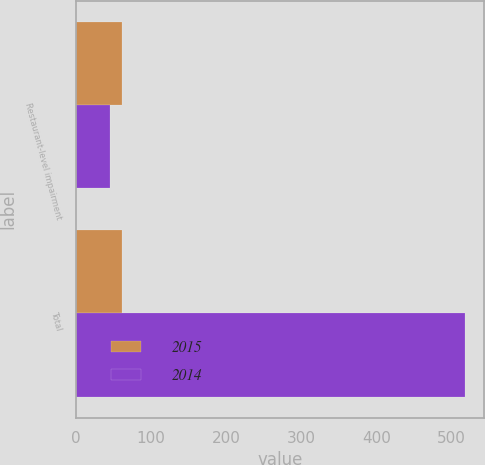Convert chart. <chart><loc_0><loc_0><loc_500><loc_500><stacked_bar_chart><ecel><fcel>Restaurant-level impairment<fcel>Total<nl><fcel>2015<fcel>61<fcel>61<nl><fcel>2014<fcel>46<fcel>518<nl></chart> 